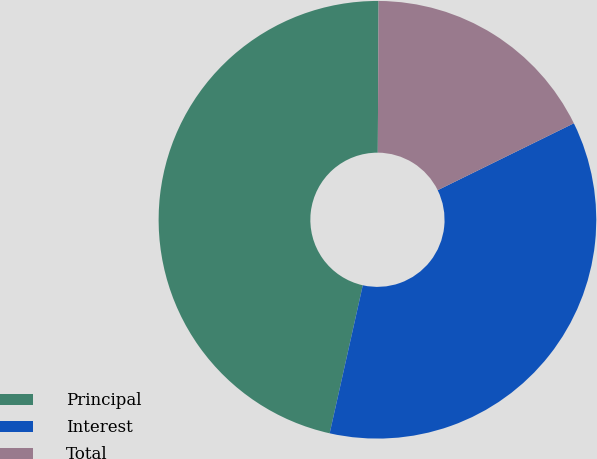Convert chart. <chart><loc_0><loc_0><loc_500><loc_500><pie_chart><fcel>Principal<fcel>Interest<fcel>Total<nl><fcel>46.58%<fcel>35.77%<fcel>17.65%<nl></chart> 